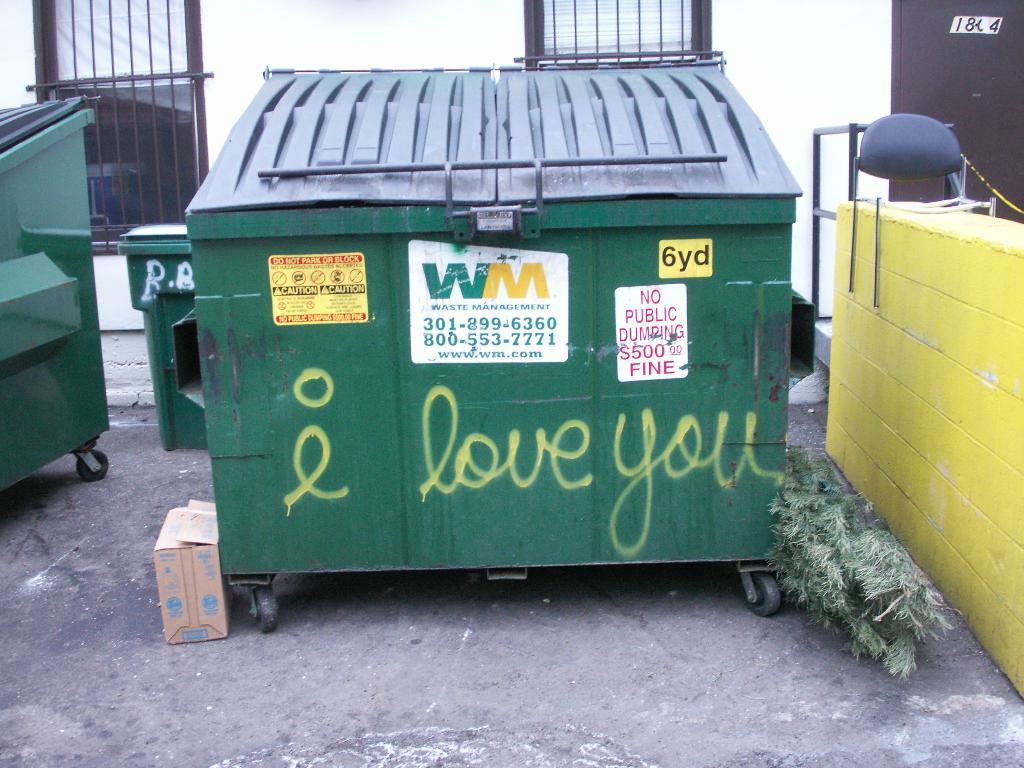<image>
Write a terse but informative summary of the picture. Love you is written in yellow on a green dumpster. 